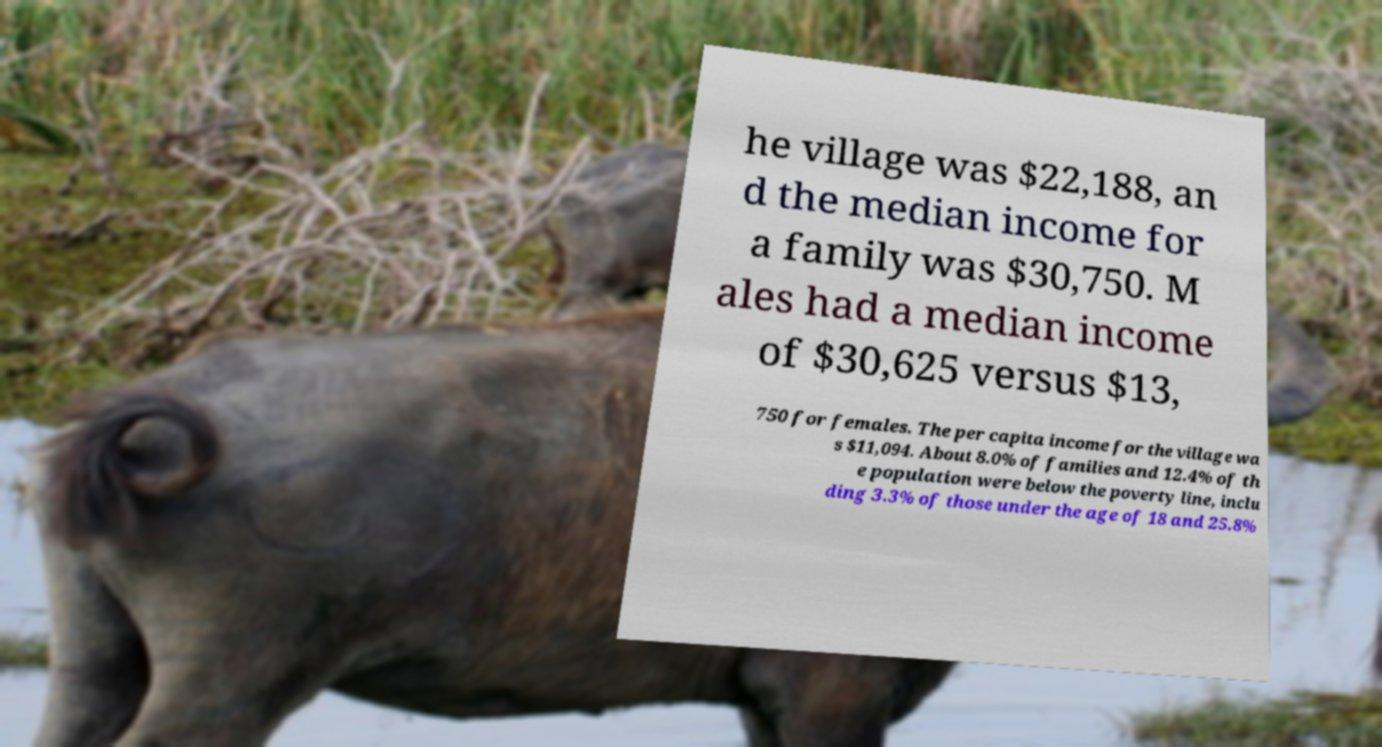Please identify and transcribe the text found in this image. he village was $22,188, an d the median income for a family was $30,750. M ales had a median income of $30,625 versus $13, 750 for females. The per capita income for the village wa s $11,094. About 8.0% of families and 12.4% of th e population were below the poverty line, inclu ding 3.3% of those under the age of 18 and 25.8% 